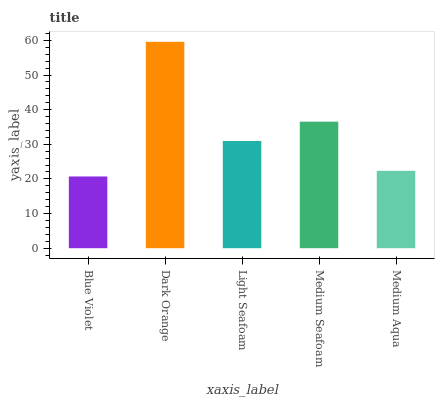Is Blue Violet the minimum?
Answer yes or no. Yes. Is Dark Orange the maximum?
Answer yes or no. Yes. Is Light Seafoam the minimum?
Answer yes or no. No. Is Light Seafoam the maximum?
Answer yes or no. No. Is Dark Orange greater than Light Seafoam?
Answer yes or no. Yes. Is Light Seafoam less than Dark Orange?
Answer yes or no. Yes. Is Light Seafoam greater than Dark Orange?
Answer yes or no. No. Is Dark Orange less than Light Seafoam?
Answer yes or no. No. Is Light Seafoam the high median?
Answer yes or no. Yes. Is Light Seafoam the low median?
Answer yes or no. Yes. Is Blue Violet the high median?
Answer yes or no. No. Is Blue Violet the low median?
Answer yes or no. No. 